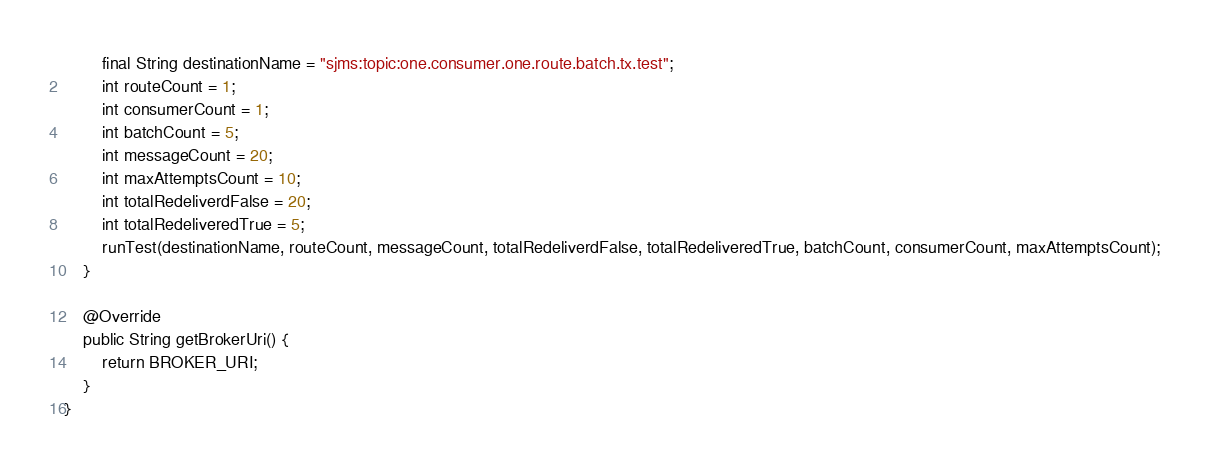<code> <loc_0><loc_0><loc_500><loc_500><_Java_>        final String destinationName = "sjms:topic:one.consumer.one.route.batch.tx.test"; 
        int routeCount = 1;
        int consumerCount = 1;
        int batchCount = 5;
        int messageCount = 20;
        int maxAttemptsCount = 10;
        int totalRedeliverdFalse = 20;
        int totalRedeliveredTrue = 5;
        runTest(destinationName, routeCount, messageCount, totalRedeliverdFalse, totalRedeliveredTrue, batchCount, consumerCount, maxAttemptsCount);
    }
    
    @Override
    public String getBrokerUri() {
        return BROKER_URI;
    }
}
</code> 